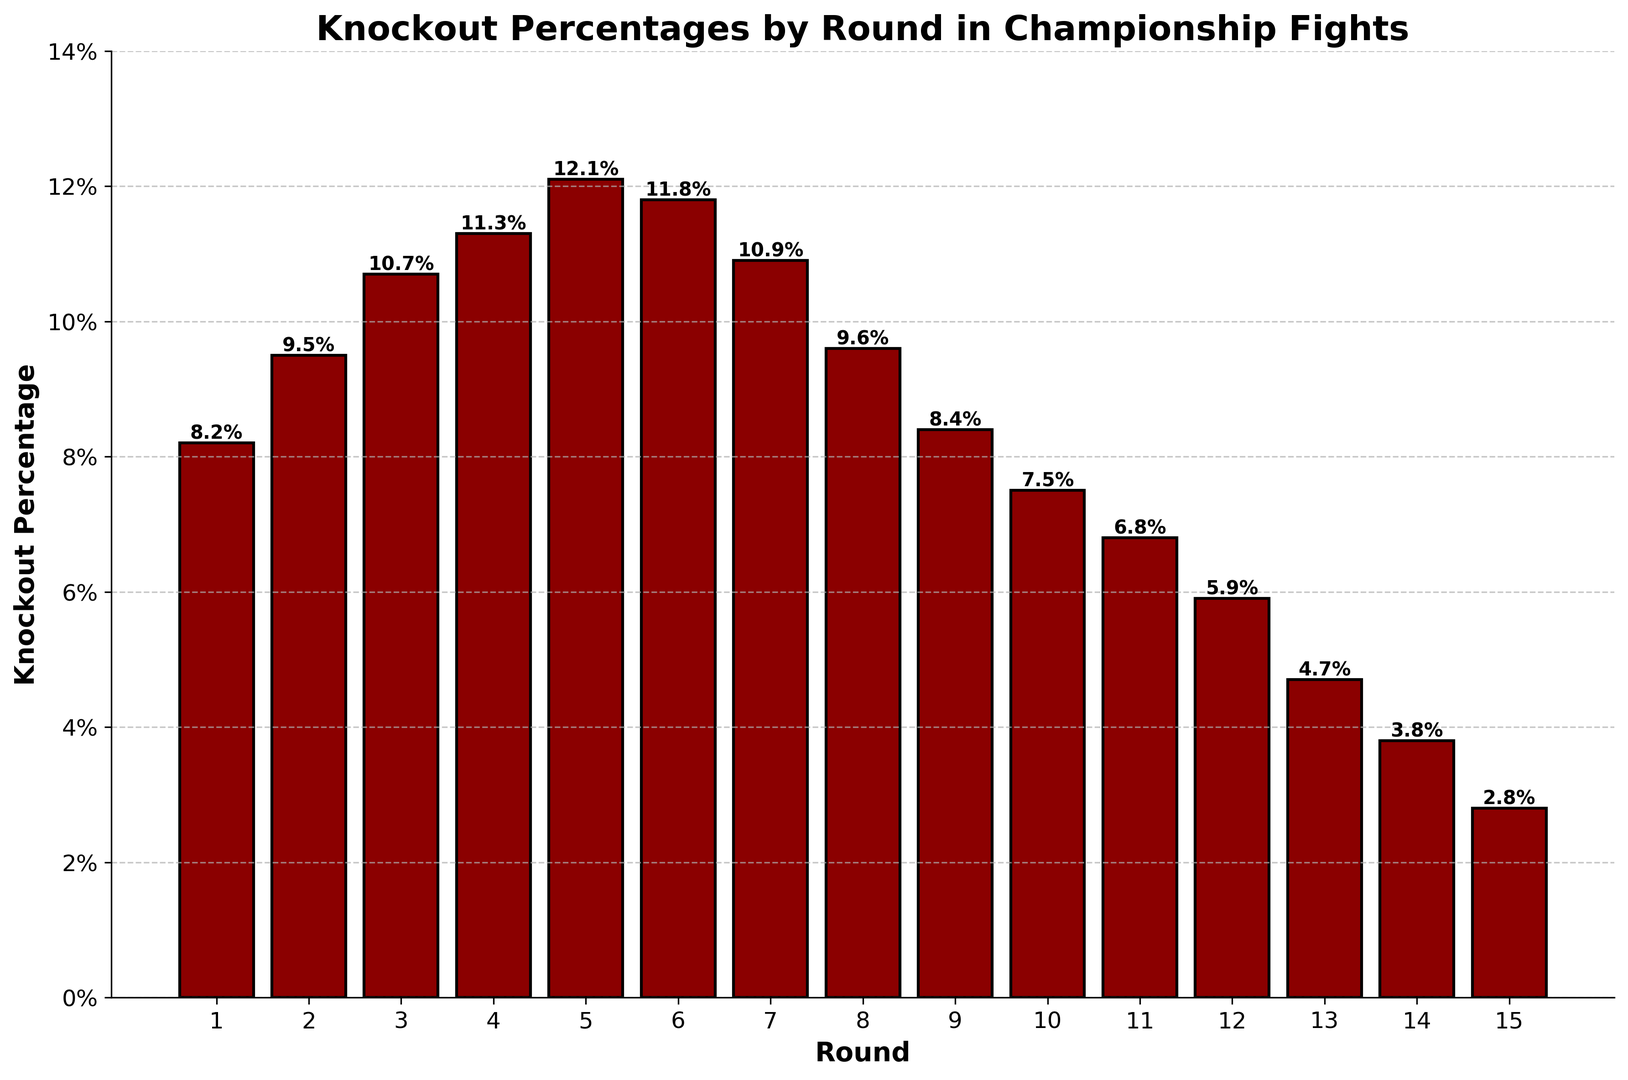In which round is the knockout percentage highest? The bar representing round 5 reaches higher than all the others.
Answer: Round 5 Which rounds have a knockout percentage less than 5%? Visually inspecting the bars, rounds 13, 14, and 15 have heights less than the 5% mark.
Answer: Rounds 13, 14, 15 How much higher is the knockout percentage in round 3 compared to round 12? The bar for round 3 is at 10.7% and the bar for round 12 is at 5.9%. The difference is 10.7% - 5.9%.
Answer: 4.8% What is the average knockout percentage from rounds 1 to 5? Adding up the percentages for rounds 1 to 5: (8.2 + 9.5 + 10.7 + 11.3 + 12.1) / 5 = 51.8 / 5.
Answer: 10.36% In which round does the knockout percentage start to decline consistently until round 15? Starting from round 6, the knockouts fall consistently each round through round 15.
Answer: Round 6 Compare the knockout percentages between rounds 7 and 8. Which is higher? The bar for round 7 is at 10.9% and for round 8 is at 9.6%.
Answer: Round 7 What is the total knockout percentage from rounds 10 to 15? Summing up the percentages for rounds 10 to 15: 7.5 + 6.8 + 5.9 + 4.7 + 3.8 + 2.8.
Answer: 31.5% What is the knockout percentage difference between the highest and lowest rounds? The highest percentage is in round 5 at 12.1% and the lowest in round 15 at 2.8%. The difference is 12.1% - 2.8%.
Answer: 9.3% How does the knockout percentage in round 4 compare to rounds 2 and 3 combined? Round 4 is at 11.3%, and rounds 2 and 3 together are 9.5% + 10.7% = 20.2%.
Answer: Round 2 and 3 combined is higher Is there a trend in the knockout percentage as the rounds progress? Early rounds (1-5) show increasing percentages, mid rounds (6-9) show a small decline, and later rounds show a consistent decrease.
Answer: Yes, initial increase, then decline 